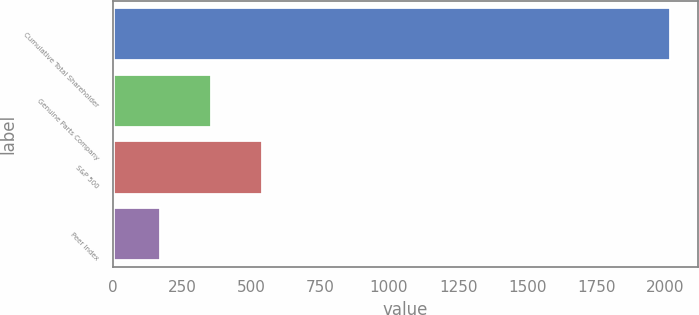<chart> <loc_0><loc_0><loc_500><loc_500><bar_chart><fcel>Cumulative Total Shareholder<fcel>Genuine Parts Company<fcel>S&P 500<fcel>Peer Index<nl><fcel>2017<fcel>356.1<fcel>540.64<fcel>171.56<nl></chart> 